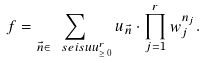<formula> <loc_0><loc_0><loc_500><loc_500>f = \sum _ { \vec { n } \in \ s e i s u u _ { \geq \, 0 } ^ { r } } u _ { \vec { n } } \cdot \prod _ { j = 1 } ^ { r } w _ { j } ^ { n _ { j } } .</formula> 